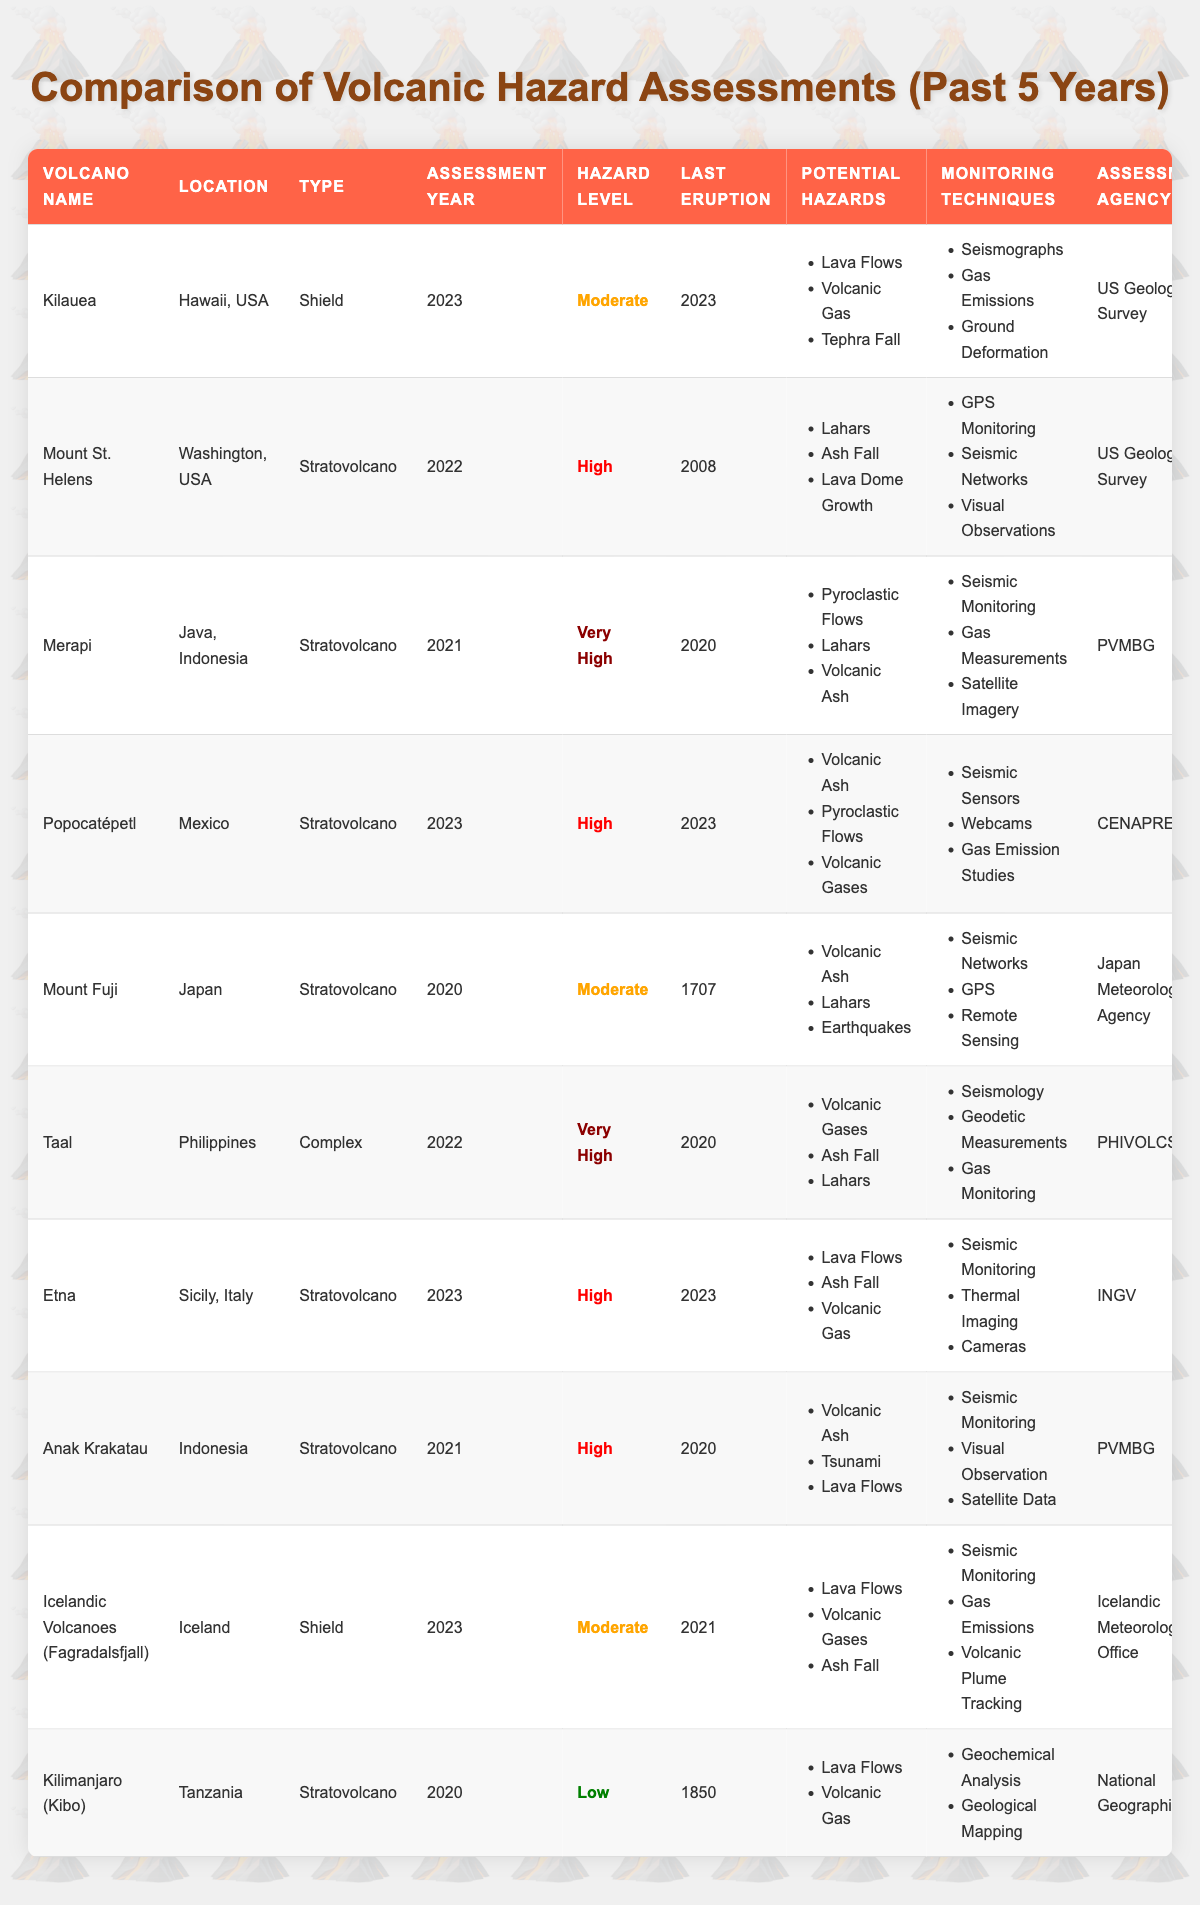What is the hazard level of Kilauea? Referring to the table, Kilauea has a hazard level listed as "Moderate" in the row corresponding to that volcano.
Answer: Moderate Which volcano has the highest hazard level according to the latest assessments? By looking at the hazard levels in the table, "Very High" represents the highest level. The volcano Merapi and Taal are both marked as "Very High."
Answer: Merapi and Taal What monitoring technique is used for Popocatépetl? The table shows that Popocatépetl uses "Seismic Sensors," "Webcams," and "Gas Emission Studies" as monitoring techniques.
Answer: Seismic Sensors, Webcams, Gas Emission Studies What is the last eruption year of Mount Fuji? The table states that the last eruption for Mount Fuji occurred in the year 1707.
Answer: 1707 How many volcanoes have a hazard level classified as "High"? Referring to the table, I will count the volcanoes with a hazard level of "High." These volcanoes are Mount St. Helens, Popocatépetl, Etna, and Anak Krakatau, totaling four volcanoes.
Answer: 4 Is there a volcano in the table that has not erupted since 1850? The table notes that Kilimanjaro (Kibo) last erupted in 1850, indicating it has not had an eruption since that time.
Answer: Yes What types of potential hazards are identified for Merapi? Looking at the Merapi row, the potential hazards listed are "Pyroclastic Flows," "Lahars," and "Volcanic Ash."
Answer: Pyroclastic Flows, Lahars, Volcanic Ash Which volcano has the most recent hazard assessment year listed? The table lists Kilauea, Popocatépetl, Etna, and Icelandic Volcanoes (Fagradalsfjall) with an assessment year of 2023, making them the most recent.
Answer: Kilauea, Popocatépetl, Etna, Icelandic Volcanoes What is the difference between the last eruption years of Kilauea and Kilimanjaro (Kibo)? Kilauea's last eruption is in 2023, and Kilimanjaro's is in 1850. The difference is calculated by subtracting 1850 from 2023, which equals 173 years.
Answer: 173 years Which volcano's assessment is done by the Japan Meteorological Agency? According to the table, Mount Fuji is indicated to have its assessment conducted by the Japan Meteorological Agency.
Answer: Mount Fuji 